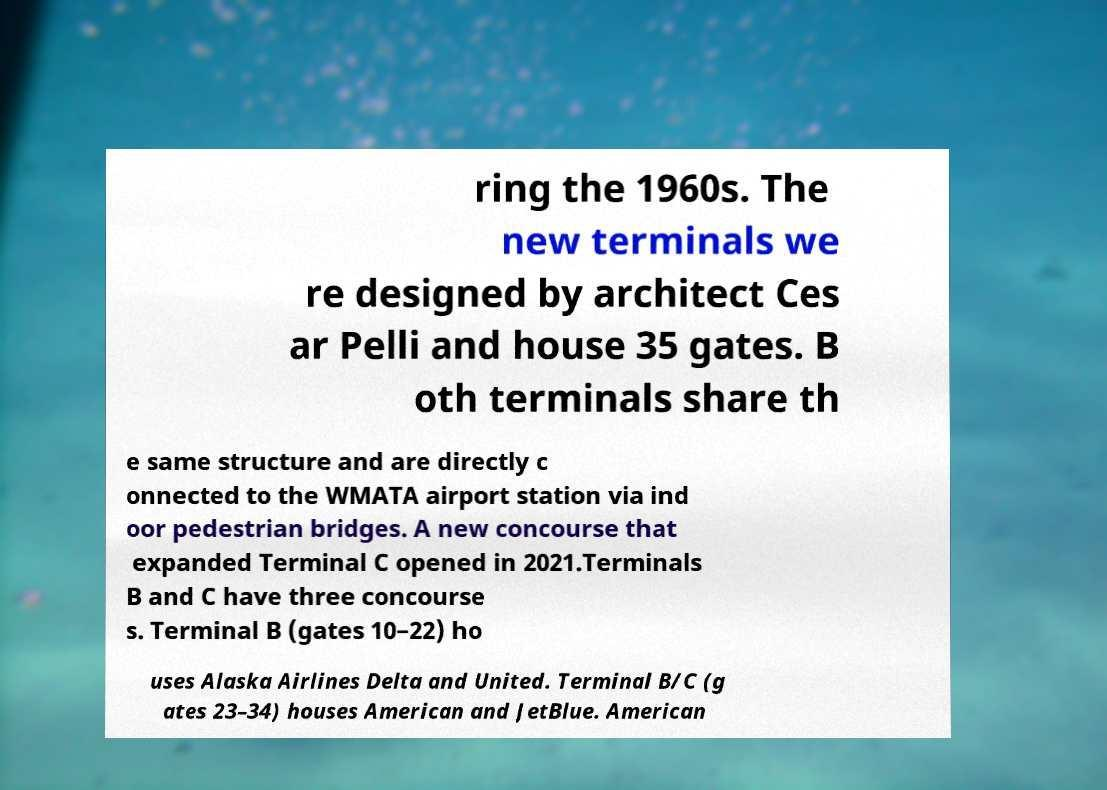Please read and relay the text visible in this image. What does it say? ring the 1960s. The new terminals we re designed by architect Ces ar Pelli and house 35 gates. B oth terminals share th e same structure and are directly c onnected to the WMATA airport station via ind oor pedestrian bridges. A new concourse that expanded Terminal C opened in 2021.Terminals B and C have three concourse s. Terminal B (gates 10–22) ho uses Alaska Airlines Delta and United. Terminal B/C (g ates 23–34) houses American and JetBlue. American 